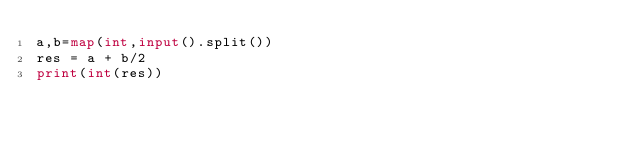<code> <loc_0><loc_0><loc_500><loc_500><_Python_>a,b=map(int,input().split())
res = a + b/2
print(int(res))</code> 